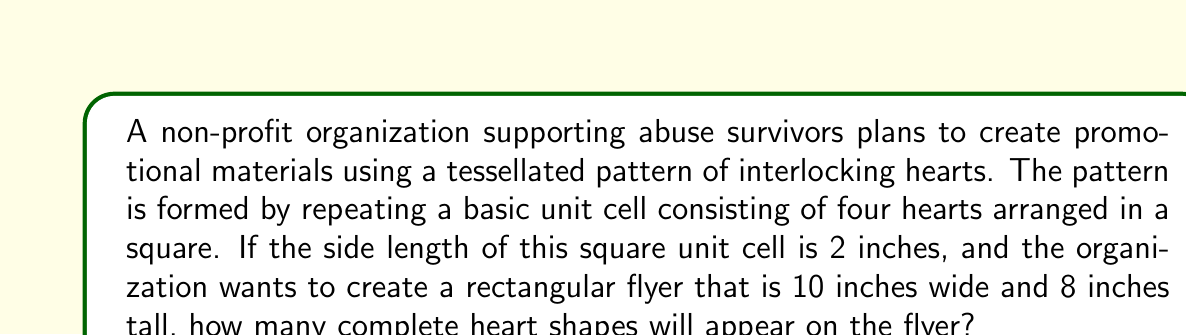Help me with this question. Let's approach this step-by-step:

1) First, we need to determine how many unit cells fit in the flyer:
   
   Width: $\frac{10 \text{ inches}}{2 \text{ inches/cell}} = 5$ cells
   Height: $\frac{8 \text{ inches}}{2 \text{ inches/cell}} = 4$ cells

2) Total number of unit cells in the flyer:
   $5 \times 4 = 20$ cells

3) Each unit cell contains 4 hearts, so the total number of hearts is:
   $20 \text{ cells} \times 4 \text{ hearts/cell} = 80$ hearts

Therefore, the flyer will contain 80 complete heart shapes.

[asy]
unitsize(1cm);
for(int i=0; i<5; ++i) {
  for(int j=0; j<4; ++j) {
    draw((2*i,2*j)--(2*i+1,2*j+1)--(2*i+2,2*j), red);
    draw((2*i,2*j+2)--(2*i+1,2*j+1)--(2*i+2,2*j+2), red);
    draw((2*i,2*j)--(2*i+1,2*j+1)--(2*i,2*j+2), red);
    draw((2*i+2,2*j)--(2*i+1,2*j+1)--(2*i+2,2*j+2), red);
  }
}
draw(box((0,0),(10,8)));
label("10 inches", (5,-0.5));
label("8 inches", (10.5,4), E);
[/asy]

This diagram illustrates the tessellation of hearts on the flyer, showing the 5x4 grid of unit cells.
Answer: 80 hearts 